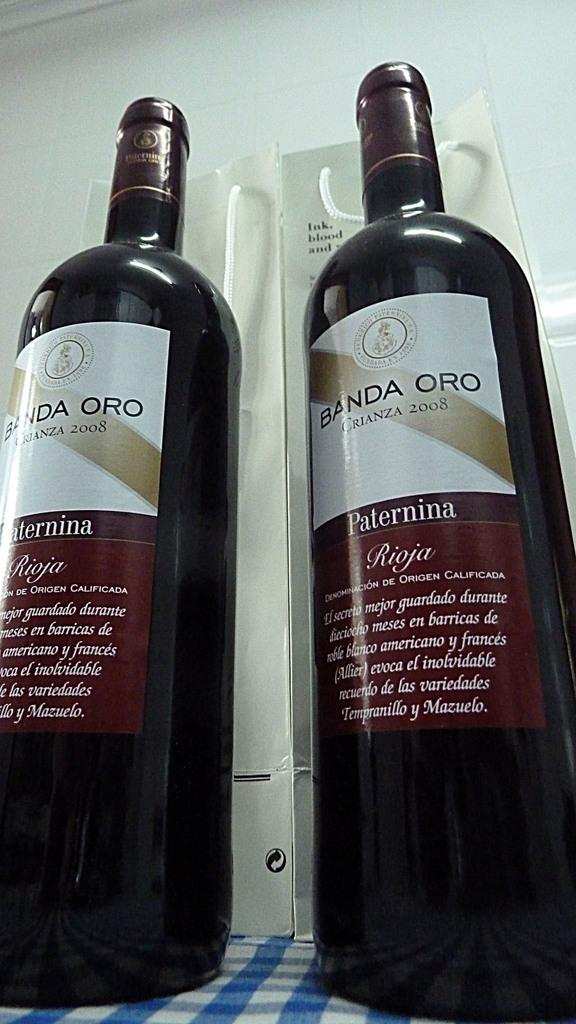<image>
Give a short and clear explanation of the subsequent image. 2 bottles of Banda Oro wine are on a blue and white checkered table top. 